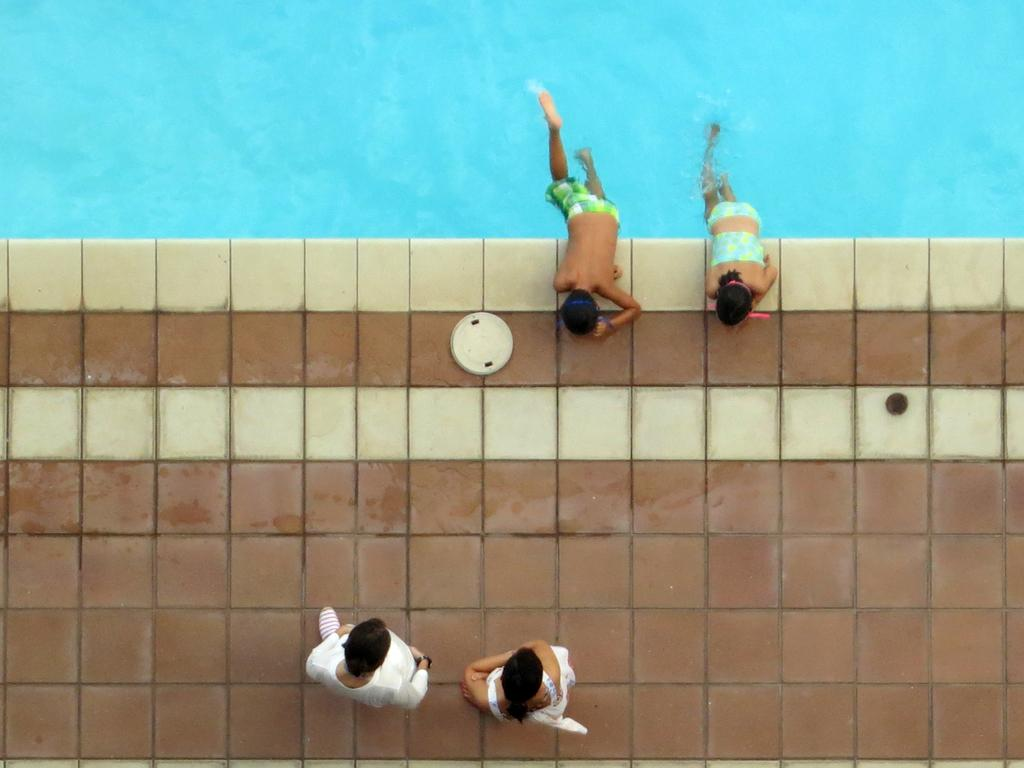What is visible in the image? There is water visible in the image. How many people are in the image? There are four people in the image. What are two of the people wearing? Two of the people are wearing white dresses. What are the other two people wearing? The other two people are wearing swimming costumes. What language is being spoken by the people in the image? The image does not provide any information about the language being spoken by the people. 